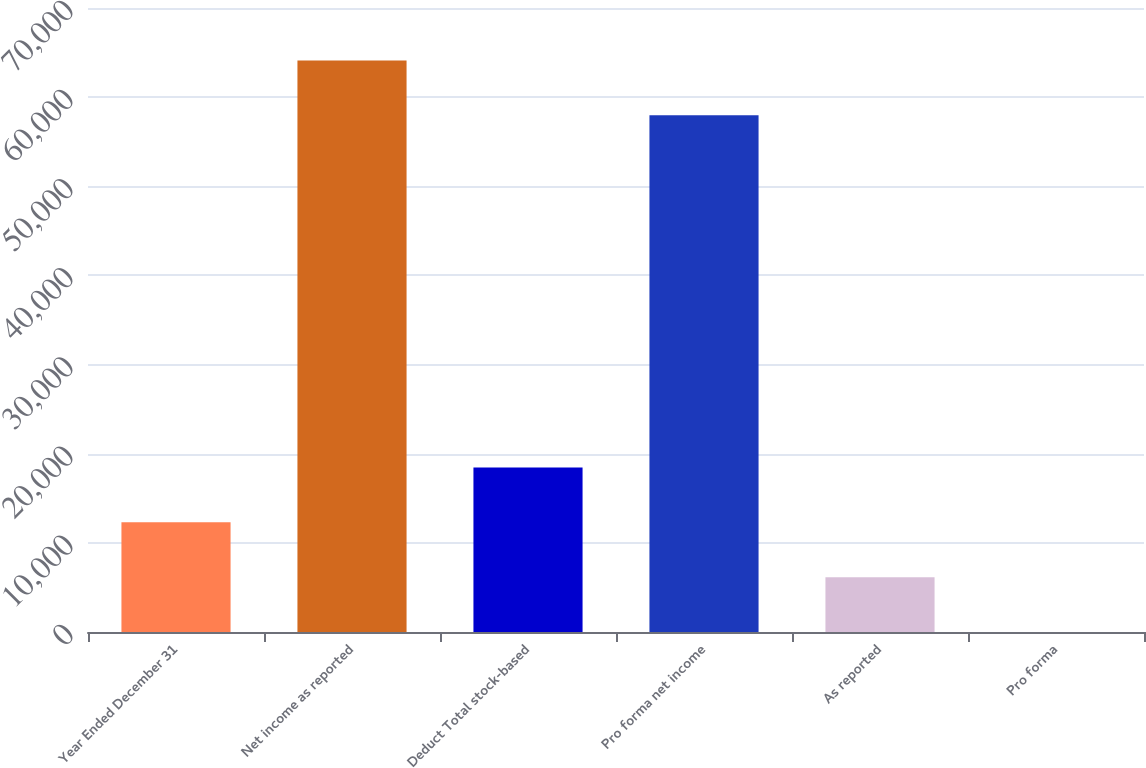Convert chart. <chart><loc_0><loc_0><loc_500><loc_500><bar_chart><fcel>Year Ended December 31<fcel>Net income as reported<fcel>Deduct Total stock-based<fcel>Pro forma net income<fcel>As reported<fcel>Pro forma<nl><fcel>12306.8<fcel>64123.8<fcel>18459.6<fcel>57971<fcel>6154.03<fcel>1.26<nl></chart> 